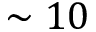<formula> <loc_0><loc_0><loc_500><loc_500>\sim 1 0</formula> 